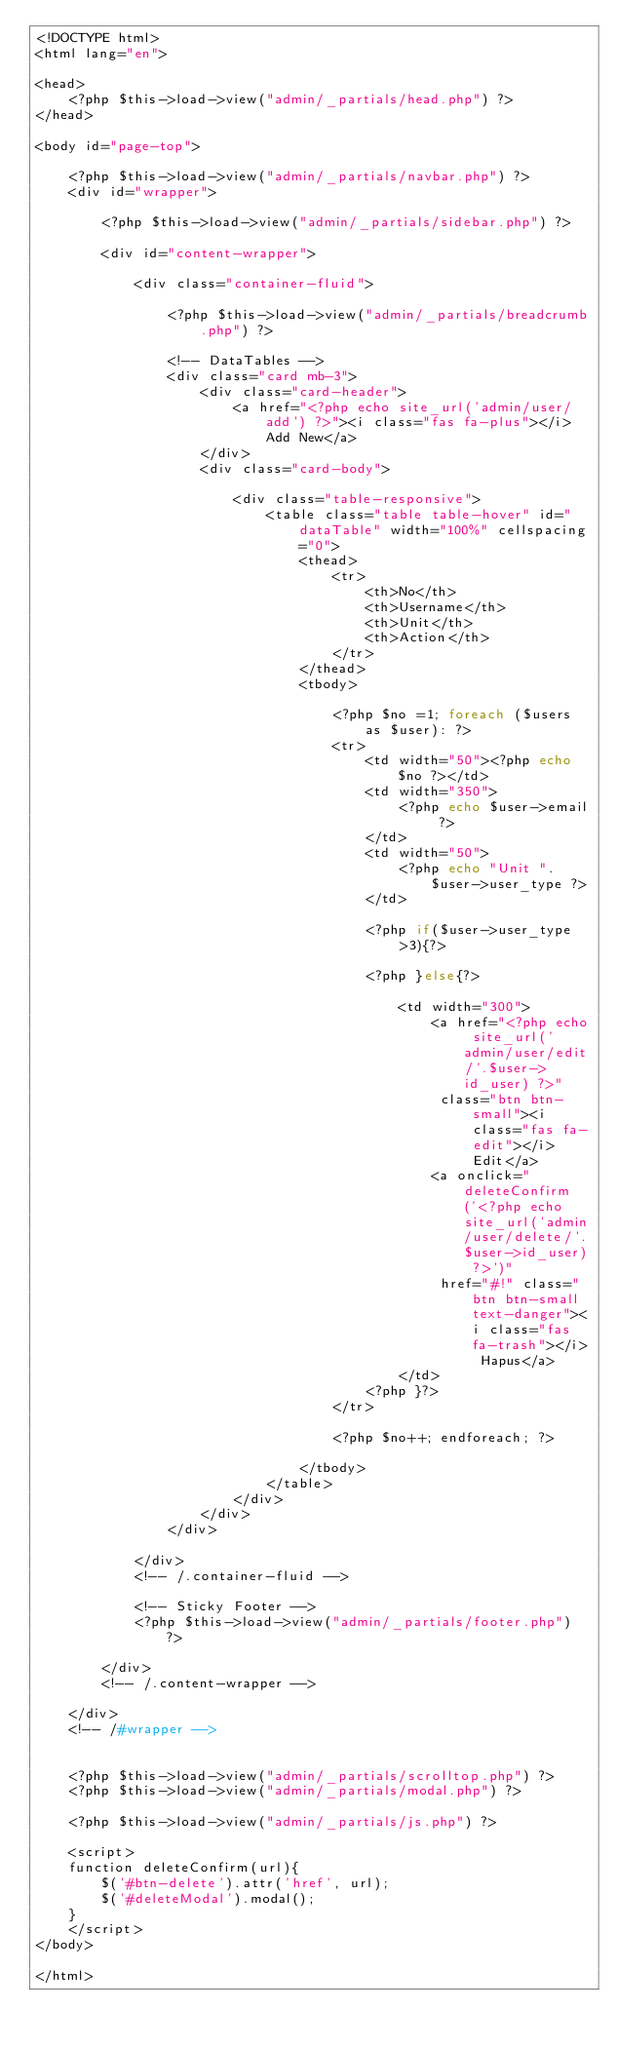<code> <loc_0><loc_0><loc_500><loc_500><_PHP_><!DOCTYPE html>
<html lang="en">

<head>
	<?php $this->load->view("admin/_partials/head.php") ?>
</head>

<body id="page-top">

	<?php $this->load->view("admin/_partials/navbar.php") ?>
	<div id="wrapper">

		<?php $this->load->view("admin/_partials/sidebar.php") ?>

		<div id="content-wrapper">

			<div class="container-fluid">

				<?php $this->load->view("admin/_partials/breadcrumb.php") ?>

				<!-- DataTables -->
				<div class="card mb-3">
					<div class="card-header">
						<a href="<?php echo site_url('admin/user/add') ?>"><i class="fas fa-plus"></i> Add New</a>
					</div>
					<div class="card-body">

						<div class="table-responsive">
							<table class="table table-hover" id="dataTable" width="100%" cellspacing="0">
								<thead>
									<tr>
										<th>No</th>
										<th>Username</th>
										<th>Unit</th>
										<th>Action</th>
									</tr>
								</thead>
								<tbody>
									
									<?php $no =1; foreach ($users as $user): ?>
									<tr>
										<td width="50"><?php echo $no ?></td>
										<td width="350">
											<?php echo $user->email ?>
										</td>
										<td width="50">
											<?php echo "Unit ".$user->user_type ?>
										</td>
										
										<?php if($user->user_type >3){?>

										<?php }else{?>

											<td width="300">
												<a href="<?php echo site_url('admin/user/edit/'.$user->id_user) ?>"
												 class="btn btn-small"><i class="fas fa-edit"></i> Edit</a>
												<a onclick="deleteConfirm('<?php echo site_url('admin/user/delete/'.$user->id_user) ?>')"
												 href="#!" class="btn btn-small text-danger"><i class="fas fa-trash"></i> Hapus</a>
											</td>
										<?php }?>
									</tr>
									
									<?php $no++; endforeach; ?>

								</tbody>
							</table>
						</div>
					</div>
				</div>

			</div>
			<!-- /.container-fluid -->

			<!-- Sticky Footer -->
			<?php $this->load->view("admin/_partials/footer.php") ?>

		</div>
		<!-- /.content-wrapper -->

	</div>
	<!-- /#wrapper -->


	<?php $this->load->view("admin/_partials/scrolltop.php") ?>
	<?php $this->load->view("admin/_partials/modal.php") ?>

	<?php $this->load->view("admin/_partials/js.php") ?>

	<script>
	function deleteConfirm(url){
		$('#btn-delete').attr('href', url);
		$('#deleteModal').modal();
	}
	</script>
</body>

</html>
</code> 